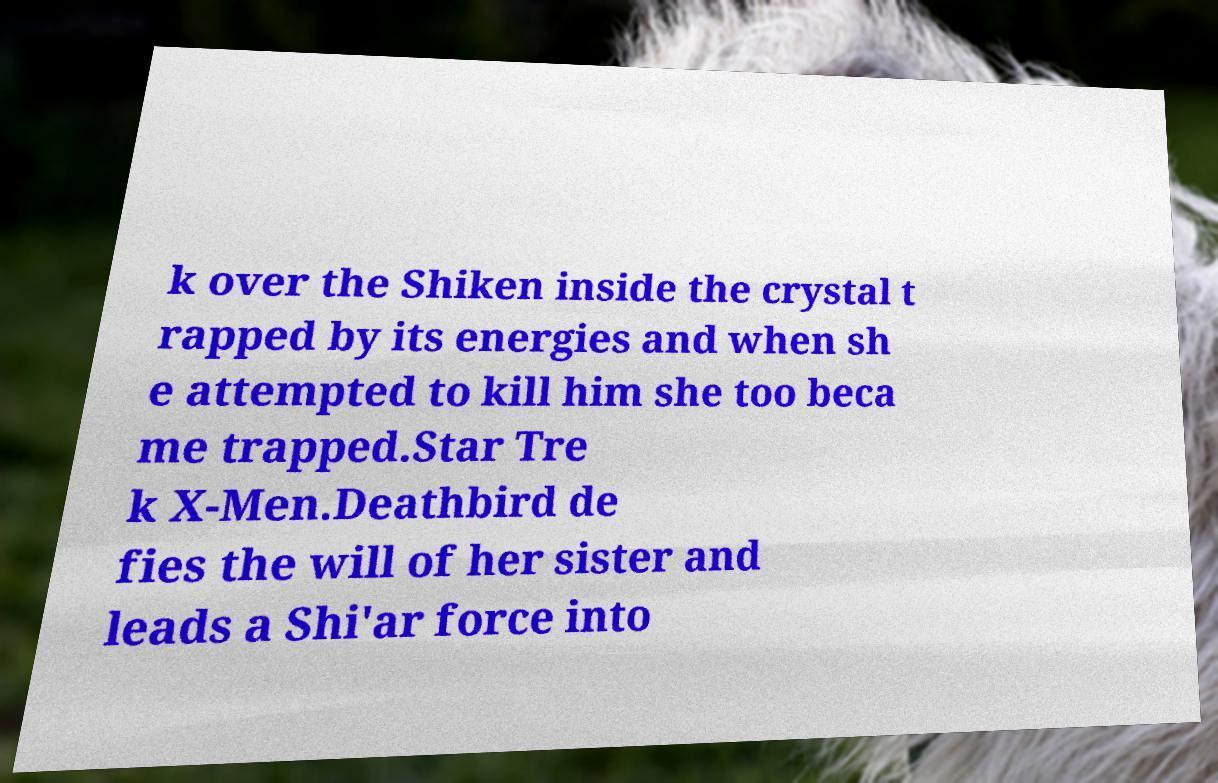I need the written content from this picture converted into text. Can you do that? k over the Shiken inside the crystal t rapped by its energies and when sh e attempted to kill him she too beca me trapped.Star Tre k X-Men.Deathbird de fies the will of her sister and leads a Shi'ar force into 